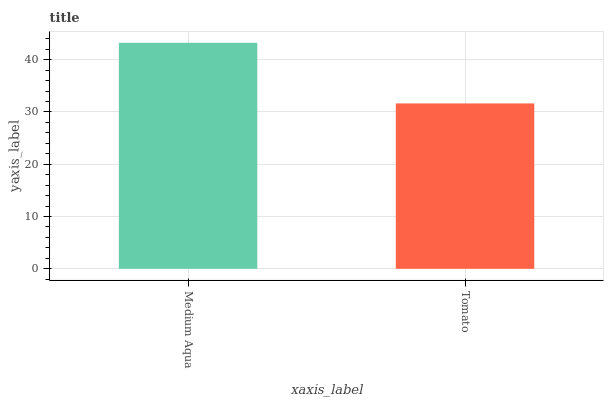Is Tomato the minimum?
Answer yes or no. Yes. Is Medium Aqua the maximum?
Answer yes or no. Yes. Is Tomato the maximum?
Answer yes or no. No. Is Medium Aqua greater than Tomato?
Answer yes or no. Yes. Is Tomato less than Medium Aqua?
Answer yes or no. Yes. Is Tomato greater than Medium Aqua?
Answer yes or no. No. Is Medium Aqua less than Tomato?
Answer yes or no. No. Is Medium Aqua the high median?
Answer yes or no. Yes. Is Tomato the low median?
Answer yes or no. Yes. Is Tomato the high median?
Answer yes or no. No. Is Medium Aqua the low median?
Answer yes or no. No. 